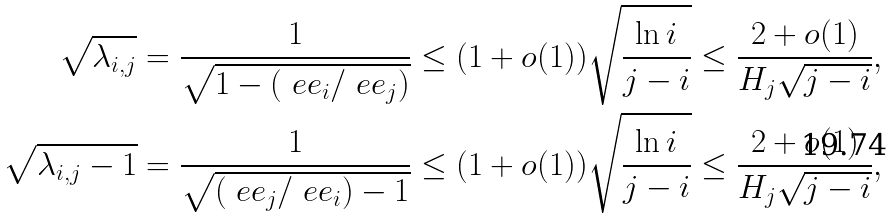Convert formula to latex. <formula><loc_0><loc_0><loc_500><loc_500>\sqrt { \lambda _ { i , j } } & = \frac { 1 } { \sqrt { 1 - ( \ e e _ { i } / \ e e _ { j } ) } } \leq ( 1 + o ( 1 ) ) \sqrt { \frac { \ln i } { j - i } } \leq \frac { 2 + o ( 1 ) } { H _ { j } \sqrt { j - i } } , \\ \sqrt { \lambda _ { i , j } - 1 } & = \frac { 1 } { \sqrt { ( \ e e _ { j } / \ e e _ { i } ) - 1 } } \leq ( 1 + o ( 1 ) ) \sqrt { \frac { \ln i } { j - i } } \leq \frac { 2 + o ( 1 ) } { H _ { j } \sqrt { j - i } } ,</formula> 